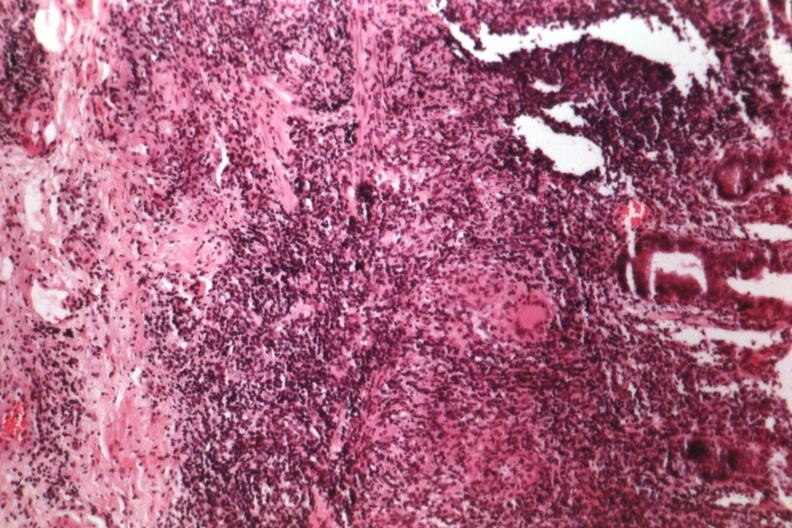what is present?
Answer the question using a single word or phrase. Colon 